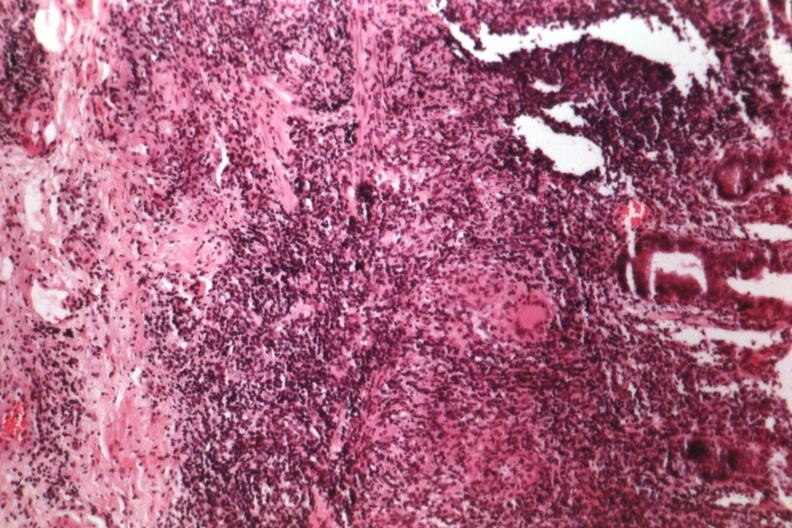what is present?
Answer the question using a single word or phrase. Colon 